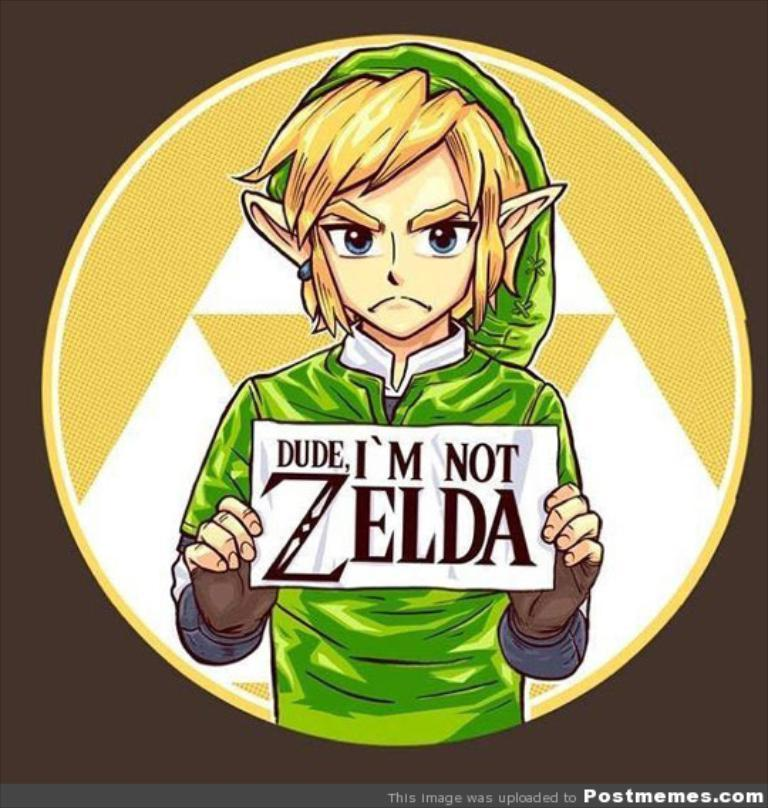<image>
Provide a brief description of the given image. A meme with Link on it that says Dude, I'm not Zelda. 